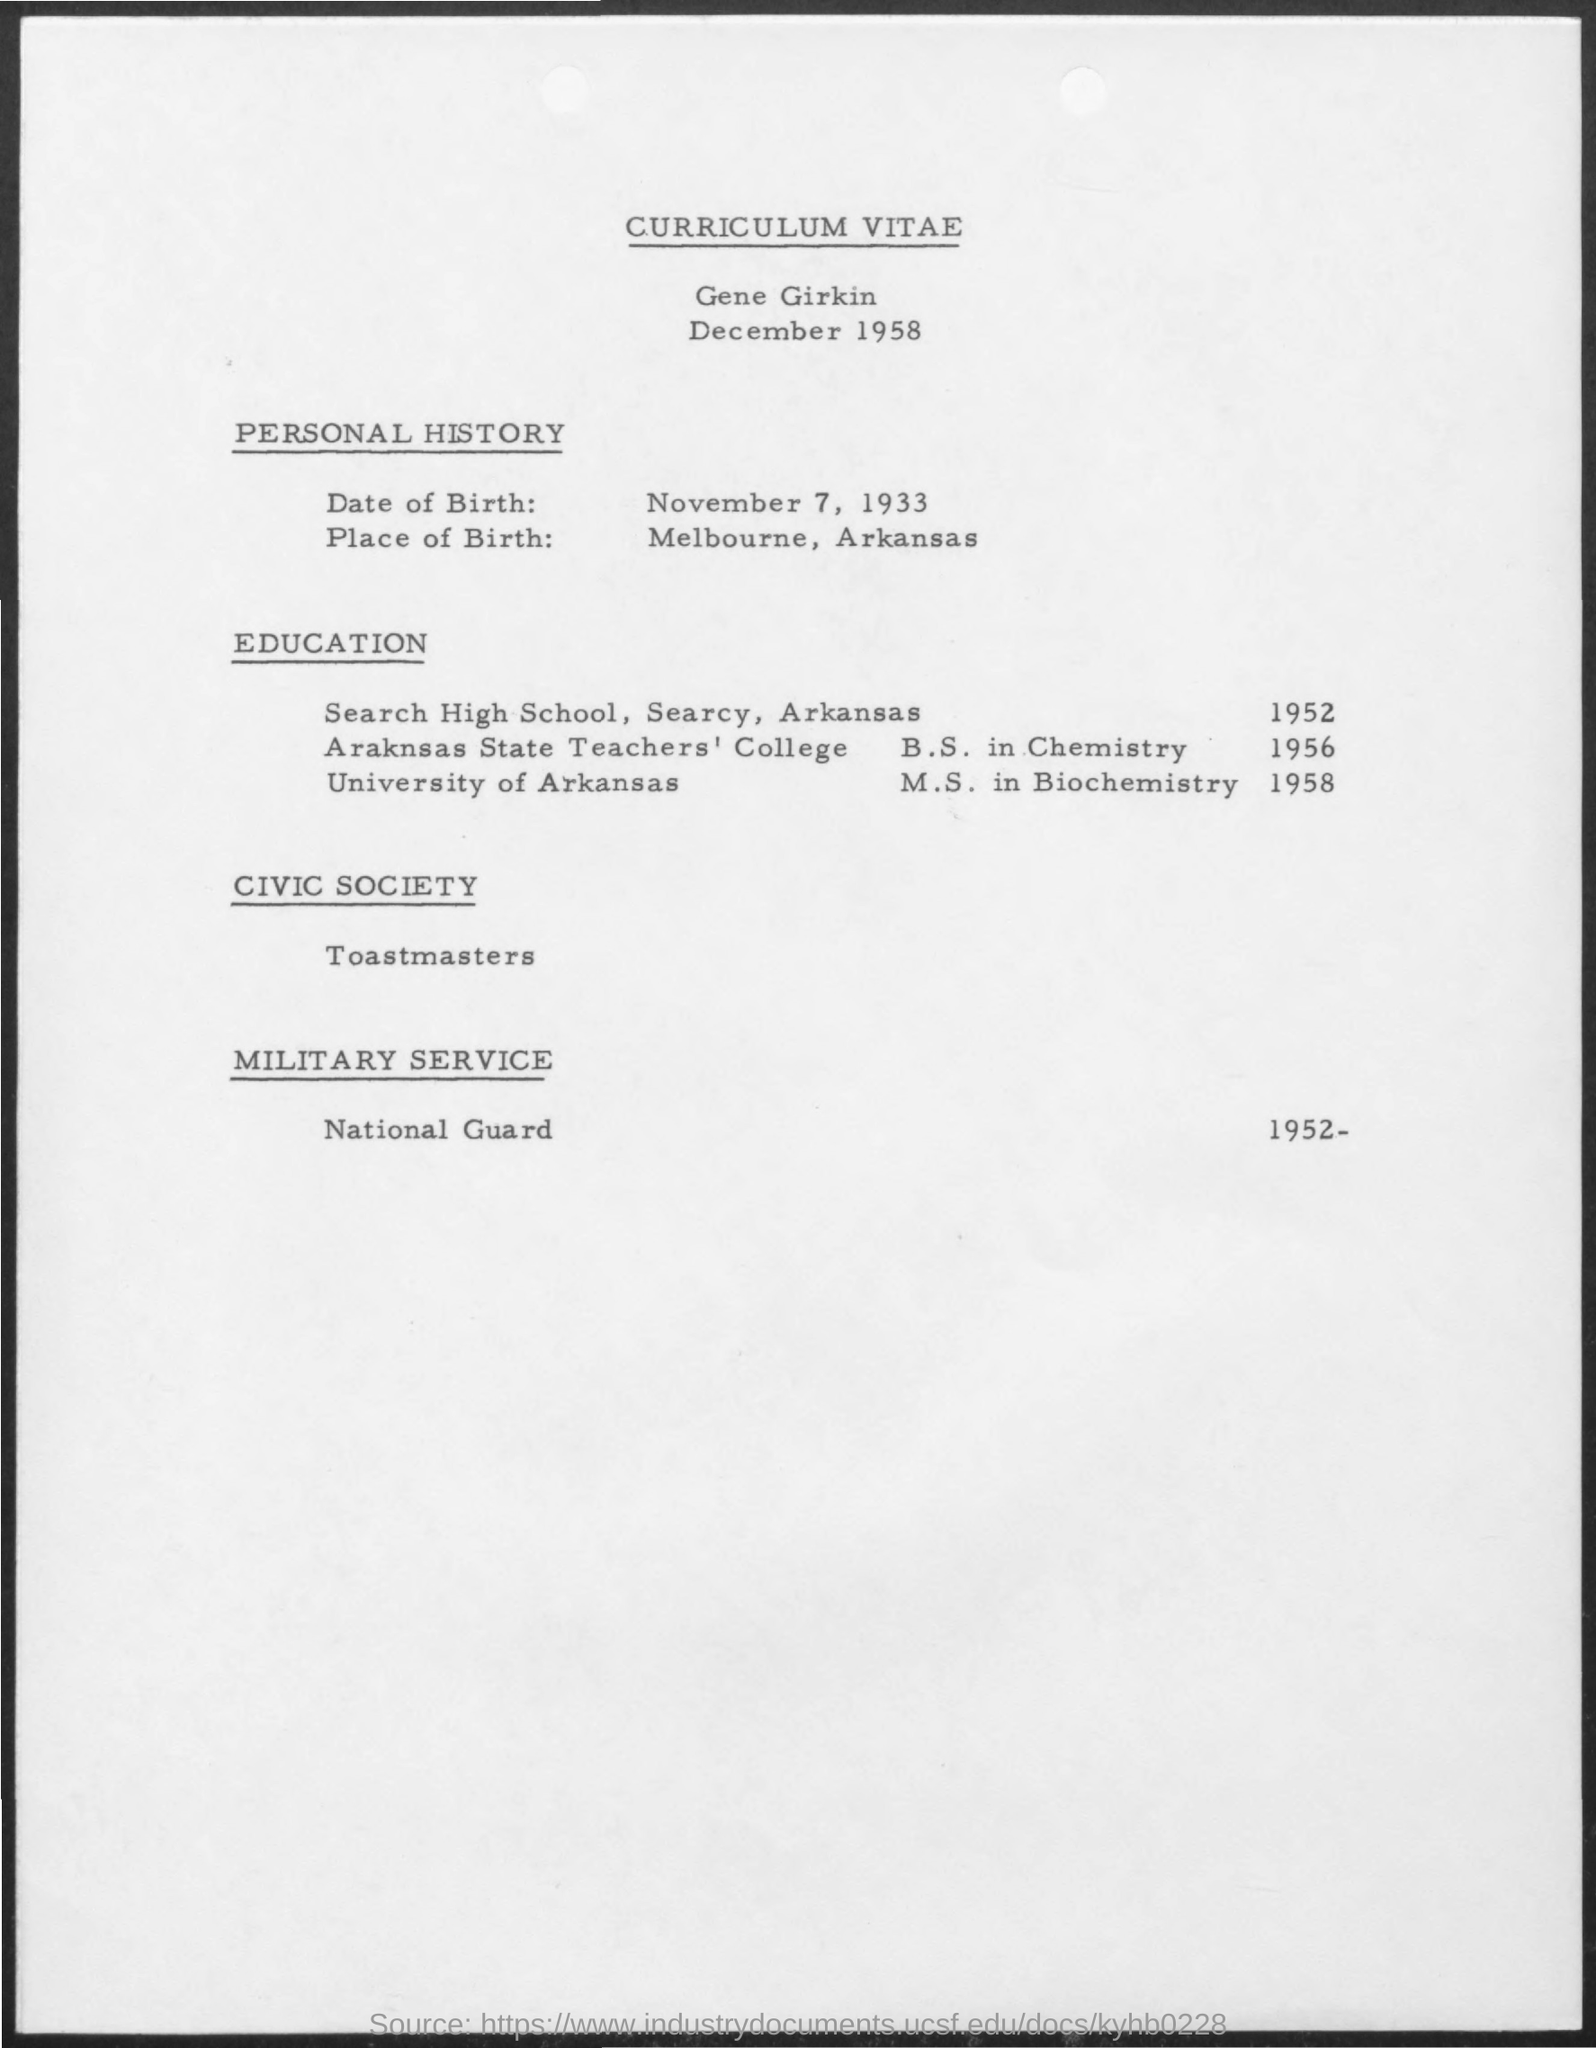What is the date mentioned ?
Make the answer very short. December 1958. What is the date of birth mentioned ?
Your response must be concise. November 7, 1933. What is the place of birth mentioned ?
Your response must be concise. Melbourne , arkansas. What is the name of civic society mentioned ?
Provide a succinct answer. Toastmasters. What is the name of military service mentioned ?
Give a very brief answer. National guard. 